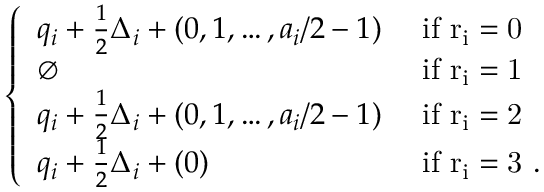<formula> <loc_0><loc_0><loc_500><loc_500>\left \{ \begin{array} { l l } { q _ { i } + \frac { 1 } { 2 } \Delta _ { i } + ( 0 , 1 , \dots , a _ { i } / 2 - 1 ) } & { i f r _ { i } = 0 } \\ { \emptyset } & { i f r _ { i } = 1 } \\ { q _ { i } + \frac { 1 } { 2 } \Delta _ { i } + ( 0 , 1 , \dots , a _ { i } / 2 - 1 ) } & { i f r _ { i } = 2 } \\ { q _ { i } + \frac { 1 } { 2 } \Delta _ { i } + ( 0 ) } & { i f r _ { i } = 3 . } \end{array}</formula> 